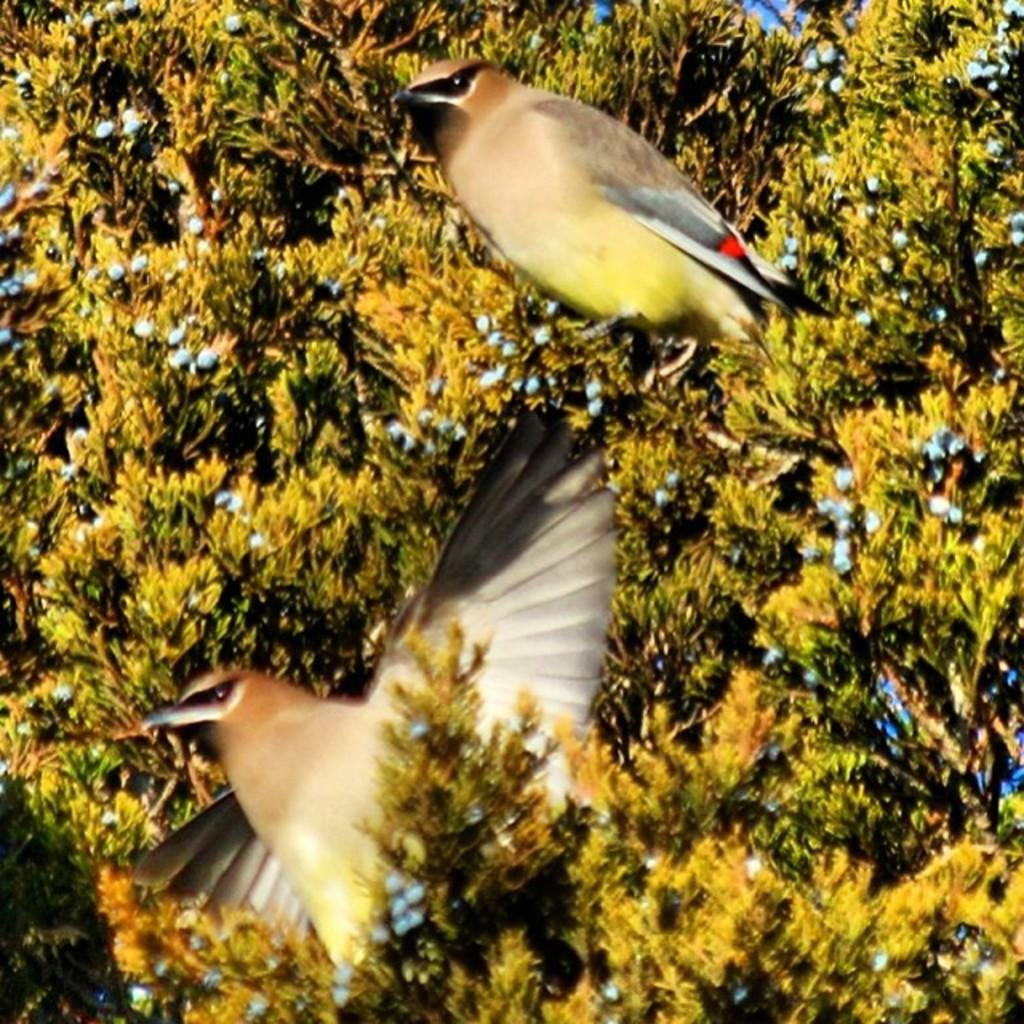What type of vegetation can be seen in the image? There are trees in the image. How many birds are present in the image? There are two birds in the image. What type of design can be seen on the grandmother's apron in the image? There is no grandmother or apron present in the image; it features trees and birds. How does the ice affect the movement of the birds in the image? There is no ice present in the image, and therefore no impact on the birds' movement can be observed. 